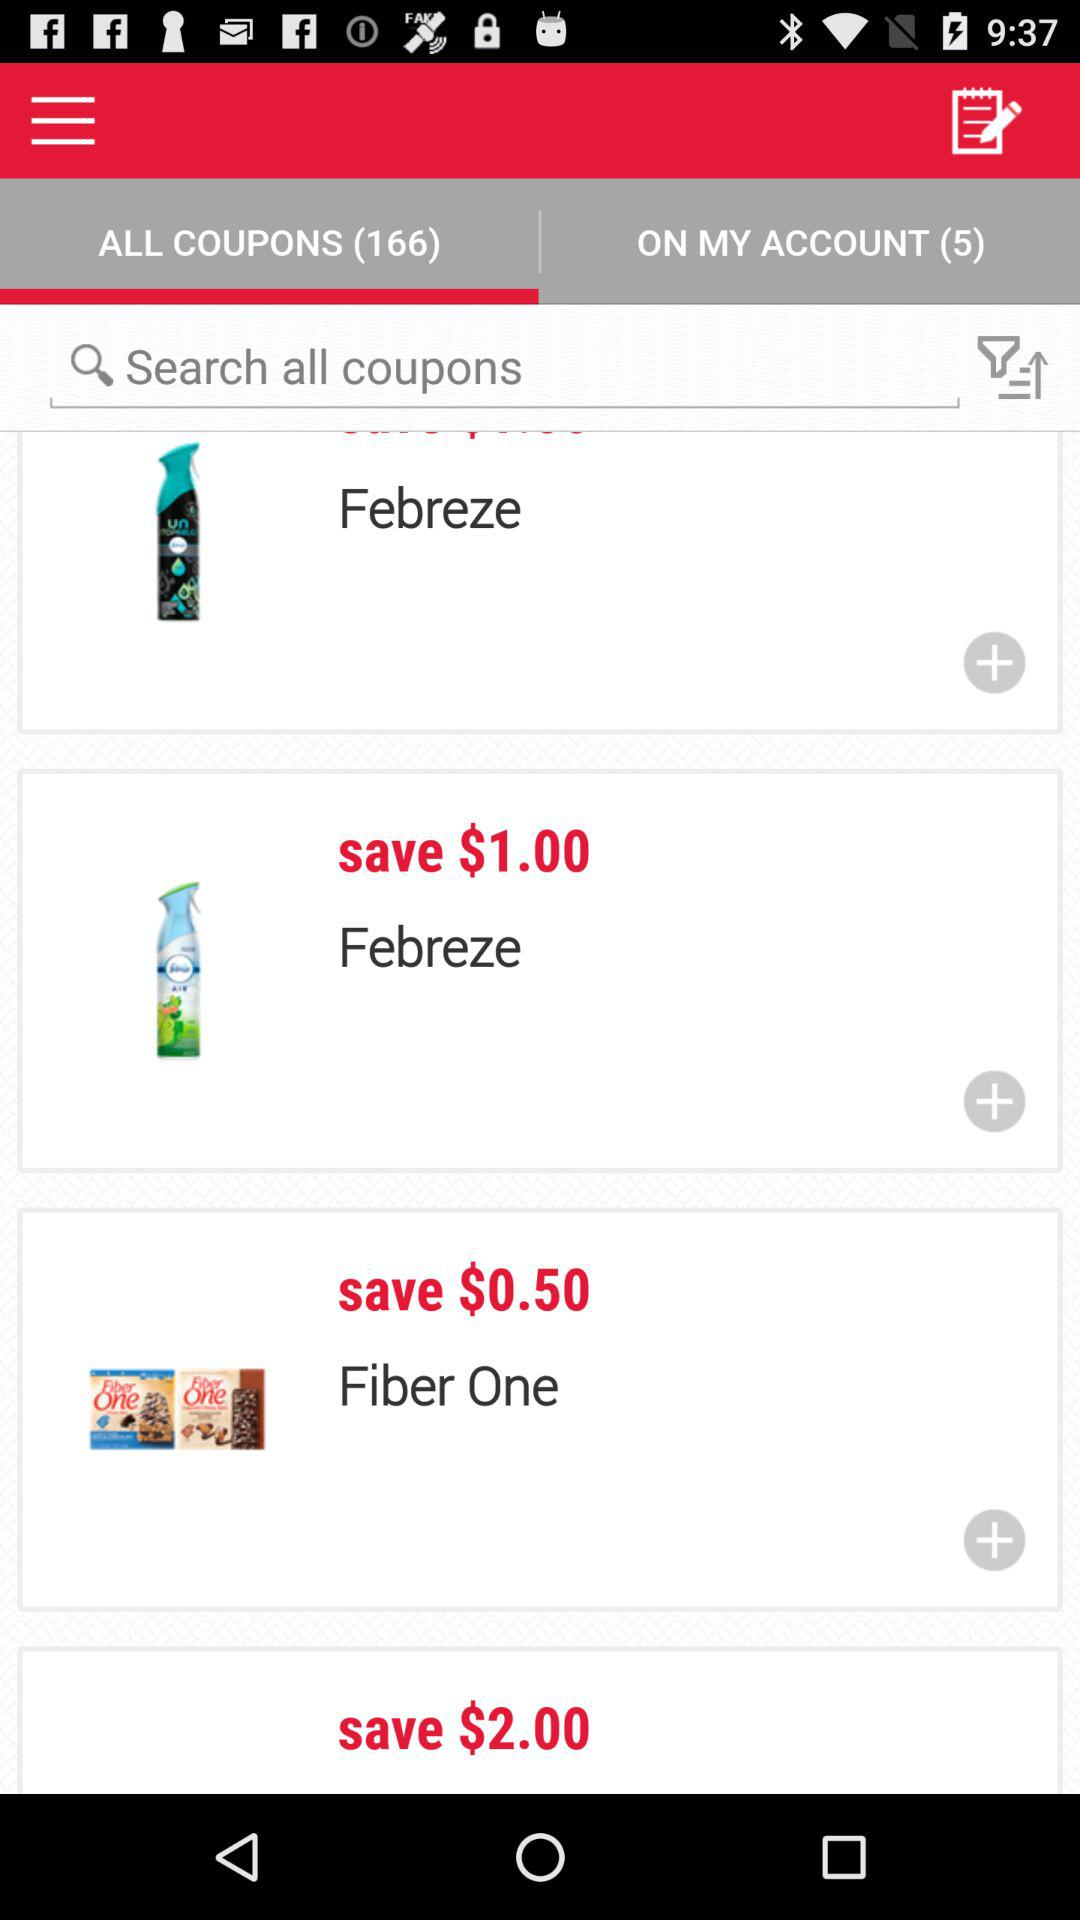Which tab is selected? The selected tab is "ALL COUPONS (166)". 